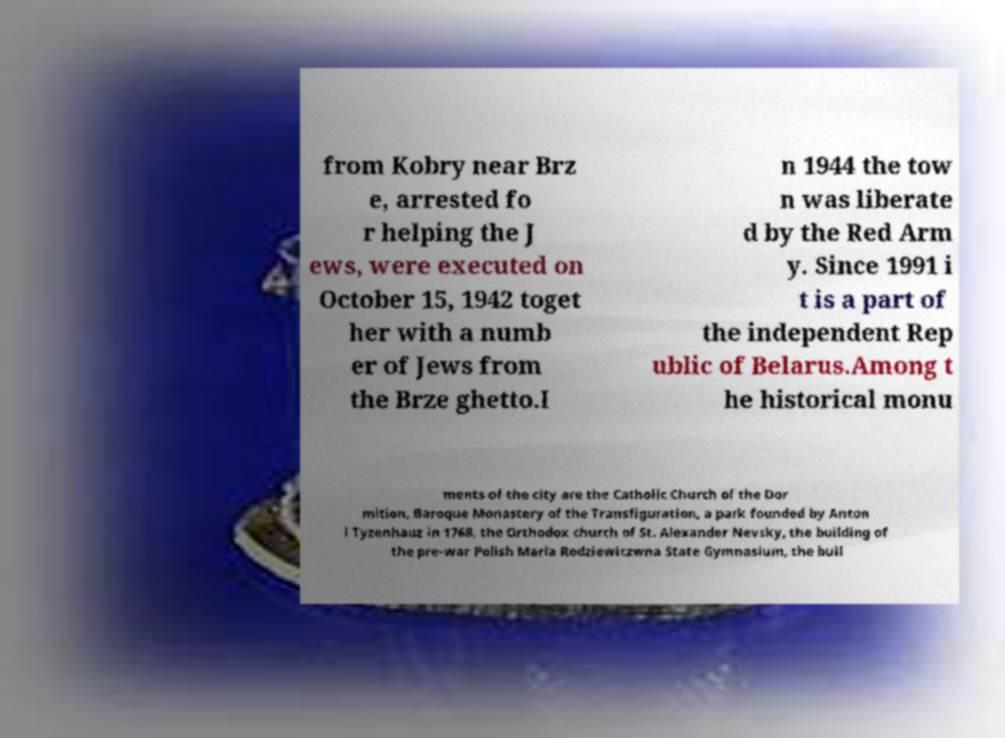For documentation purposes, I need the text within this image transcribed. Could you provide that? from Kobry near Brz e, arrested fo r helping the J ews, were executed on October 15, 1942 toget her with a numb er of Jews from the Brze ghetto.I n 1944 the tow n was liberate d by the Red Arm y. Since 1991 i t is a part of the independent Rep ublic of Belarus.Among t he historical monu ments of the city are the Catholic Church of the Dor mition, Baroque Monastery of the Transfiguration, a park founded by Anton i Tyzenhauz in 1768, the Orthodox church of St. Alexander Nevsky, the building of the pre-war Polish Maria Rodziewiczwna State Gymnasium, the buil 